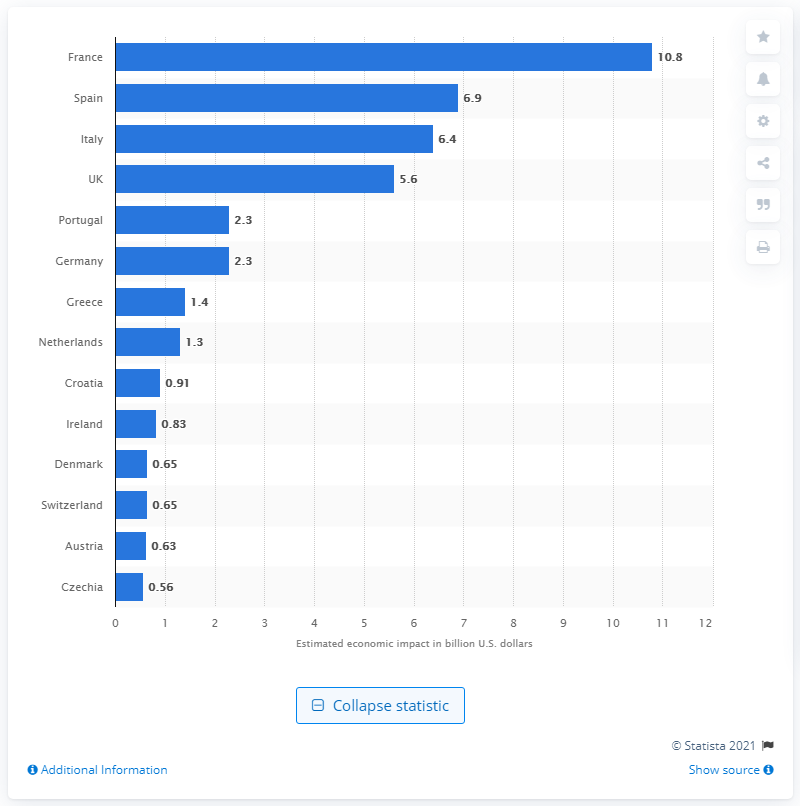Specify some key components in this picture. Airbnb made a significant contribution to the French economy in 2018, worth 10.8 billion euros. According to a recent report, Airbnb had the highest direct economic impact in France in 2018. 